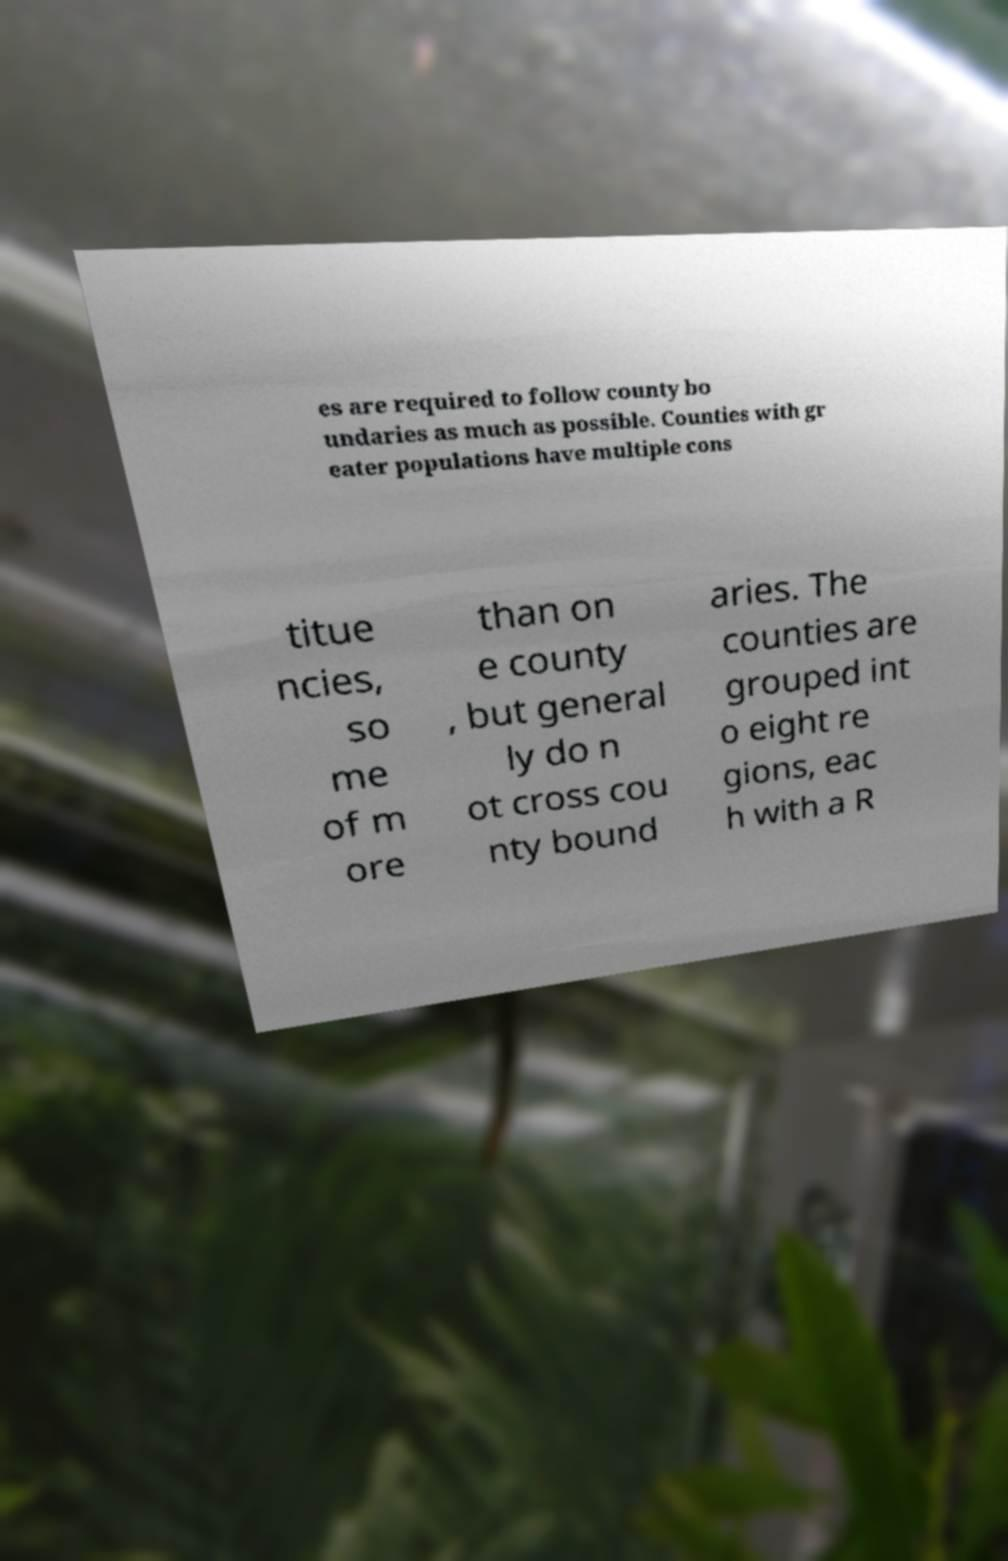Could you assist in decoding the text presented in this image and type it out clearly? es are required to follow county bo undaries as much as possible. Counties with gr eater populations have multiple cons titue ncies, so me of m ore than on e county , but general ly do n ot cross cou nty bound aries. The counties are grouped int o eight re gions, eac h with a R 